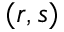<formula> <loc_0><loc_0><loc_500><loc_500>( r , s )</formula> 